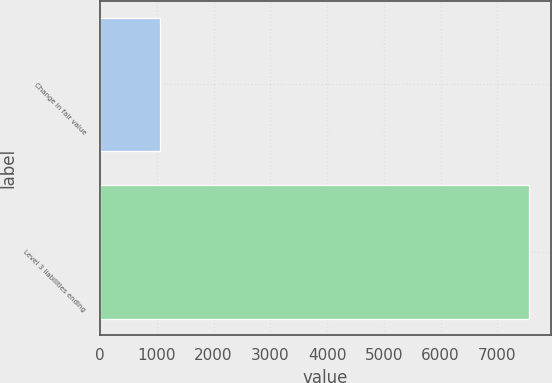Convert chart. <chart><loc_0><loc_0><loc_500><loc_500><bar_chart><fcel>Change in fair value<fcel>Level 3 liabilities ending<nl><fcel>1053<fcel>7563<nl></chart> 